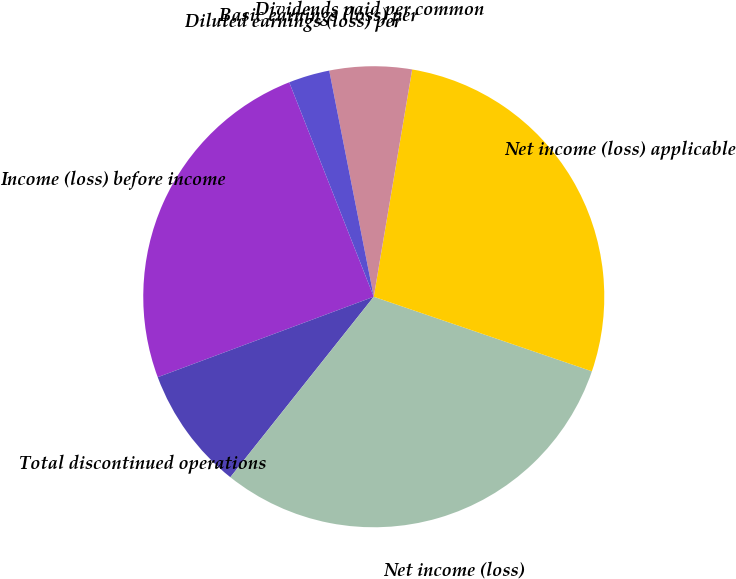Convert chart to OTSL. <chart><loc_0><loc_0><loc_500><loc_500><pie_chart><fcel>Income (loss) before income<fcel>Total discontinued operations<fcel>Net income (loss)<fcel>Net income (loss) applicable<fcel>Dividends paid per common<fcel>Basic earnings (loss) per<fcel>Diluted earnings (loss) per<nl><fcel>24.7%<fcel>8.64%<fcel>30.45%<fcel>27.58%<fcel>5.76%<fcel>0.0%<fcel>2.88%<nl></chart> 